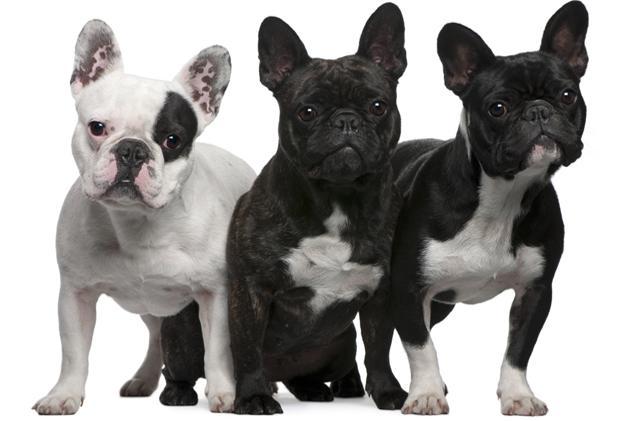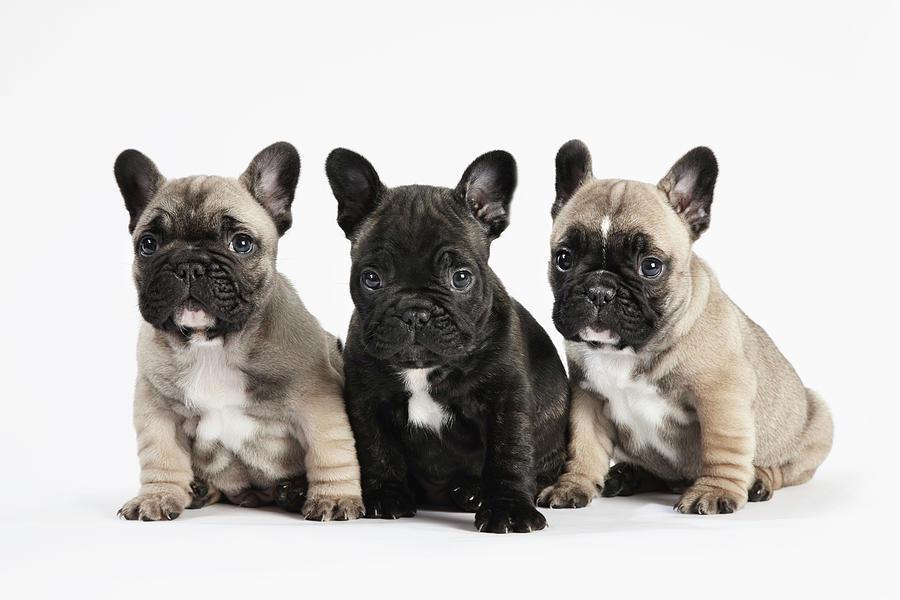The first image is the image on the left, the second image is the image on the right. Considering the images on both sides, is "There are two young dogs." valid? Answer yes or no. No. 